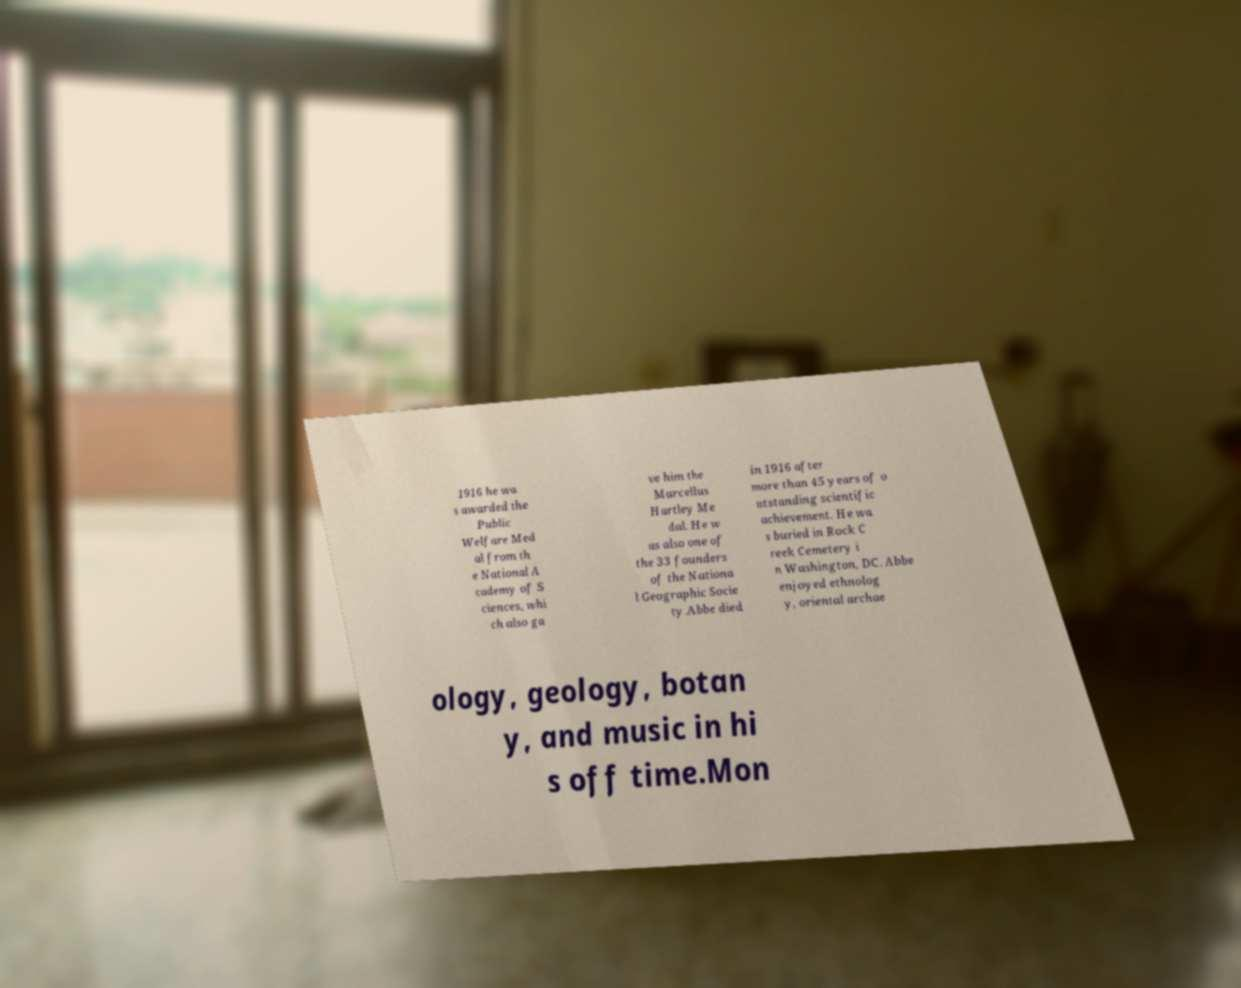Can you read and provide the text displayed in the image?This photo seems to have some interesting text. Can you extract and type it out for me? 1916 he wa s awarded the Public Welfare Med al from th e National A cademy of S ciences, whi ch also ga ve him the Marcellus Hartley Me dal. He w as also one of the 33 founders of the Nationa l Geographic Socie ty.Abbe died in 1916 after more than 45 years of o utstanding scientific achievement. He wa s buried in Rock C reek Cemetery i n Washington, DC. Abbe enjoyed ethnolog y, oriental archae ology, geology, botan y, and music in hi s off time.Mon 